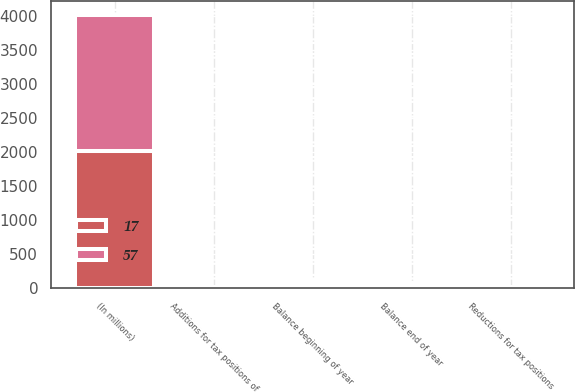<chart> <loc_0><loc_0><loc_500><loc_500><stacked_bar_chart><ecel><fcel>(In millions)<fcel>Balance beginning of year<fcel>Additions for tax positions of<fcel>Reductions for tax positions<fcel>Balance end of year<nl><fcel>17<fcel>2009<fcel>57<fcel>1<fcel>4<fcel>17<nl><fcel>57<fcel>2008<fcel>50<fcel>18<fcel>11<fcel>57<nl></chart> 